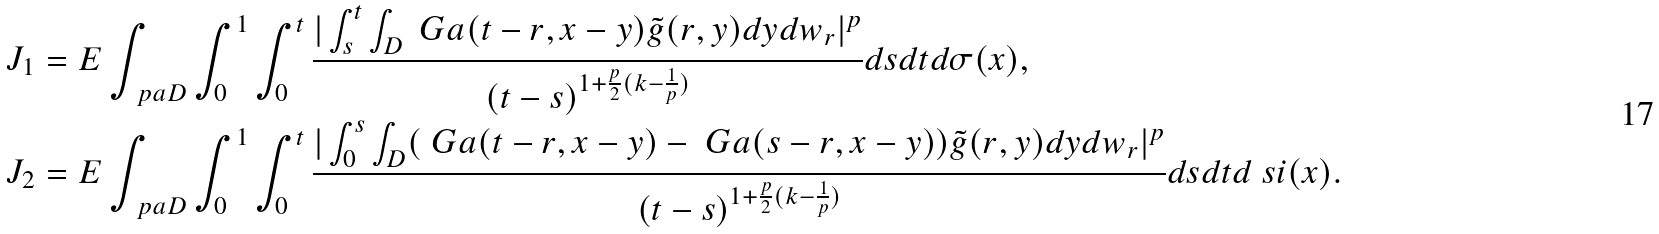Convert formula to latex. <formula><loc_0><loc_0><loc_500><loc_500>J _ { 1 } & = E \int _ { \ p a D } \int _ { 0 } ^ { 1 } \int _ { 0 } ^ { t } \frac { | \int _ { s } ^ { t } \int _ { D } \ G a ( t - r , x - y ) \tilde { g } ( r , y ) d y d w _ { r } | ^ { p } } { ( t - s ) ^ { 1 + \frac { p } 2 ( k - \frac { 1 } { p } ) } } d s d t d \sigma ( x ) , \\ J _ { 2 } & = E \int _ { \ p a D } \int _ { 0 } ^ { 1 } \int _ { 0 } ^ { t } \frac { | \int _ { 0 } ^ { s } \int _ { D } ( \ G a ( t - r , x - y ) - \ G a ( s - r , x - y ) ) \tilde { g } ( r , y ) d y d w _ { r } | ^ { p } } { ( t - s ) ^ { 1 + \frac { p } 2 ( k - \frac { 1 } { p } ) } } d s d t d \ s i ( x ) .</formula> 